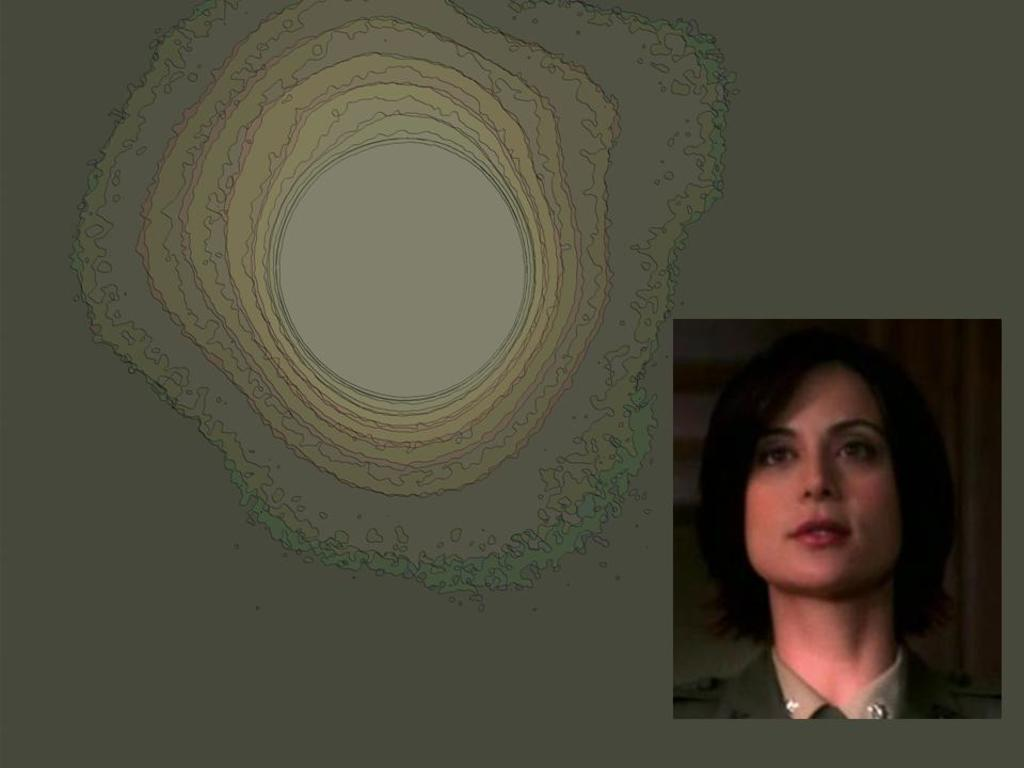What is the main subject of the image? There is a person in the image. Can you describe the background of the image? The background of the image is animated. What type of organization is hosting the event in the image? There is no event or organization present in the image; it only features a person and an animated background. 